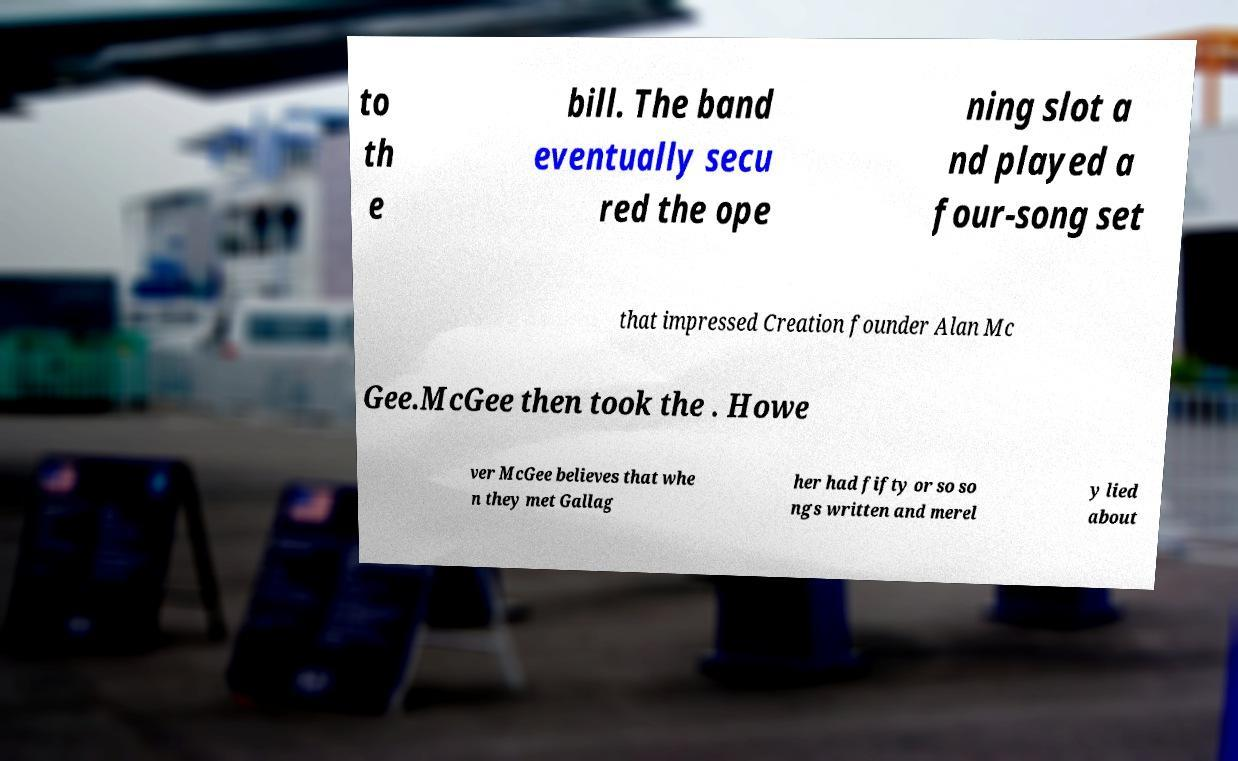There's text embedded in this image that I need extracted. Can you transcribe it verbatim? to th e bill. The band eventually secu red the ope ning slot a nd played a four-song set that impressed Creation founder Alan Mc Gee.McGee then took the . Howe ver McGee believes that whe n they met Gallag her had fifty or so so ngs written and merel y lied about 